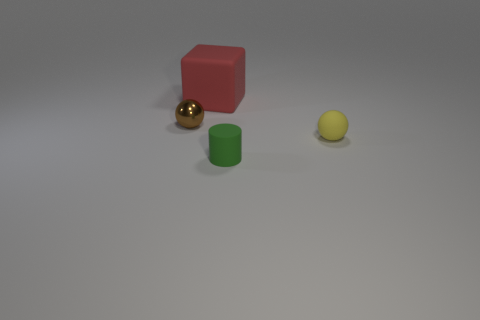Subtract 0 green balls. How many objects are left? 4 Subtract all gray cylinders. Subtract all red cubes. How many cylinders are left? 1 Subtract all yellow cylinders. How many brown blocks are left? 0 Subtract all red things. Subtract all brown shiny balls. How many objects are left? 2 Add 1 yellow matte things. How many yellow matte things are left? 2 Add 4 tiny green cylinders. How many tiny green cylinders exist? 5 Add 4 big red matte objects. How many objects exist? 8 Subtract all yellow balls. How many balls are left? 1 